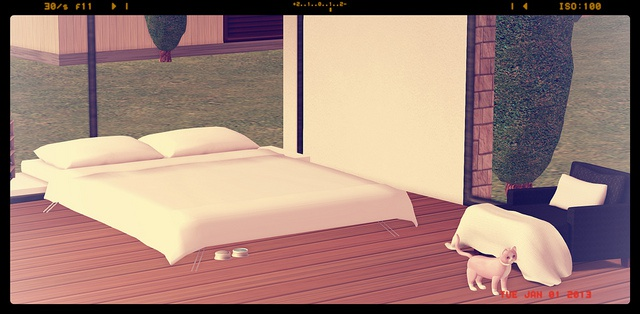Describe the objects in this image and their specific colors. I can see bed in black, tan, lightyellow, and brown tones, chair in black, navy, purple, and beige tones, couch in black, navy, purple, and beige tones, and cat in black, lightpink, tan, brown, and beige tones in this image. 